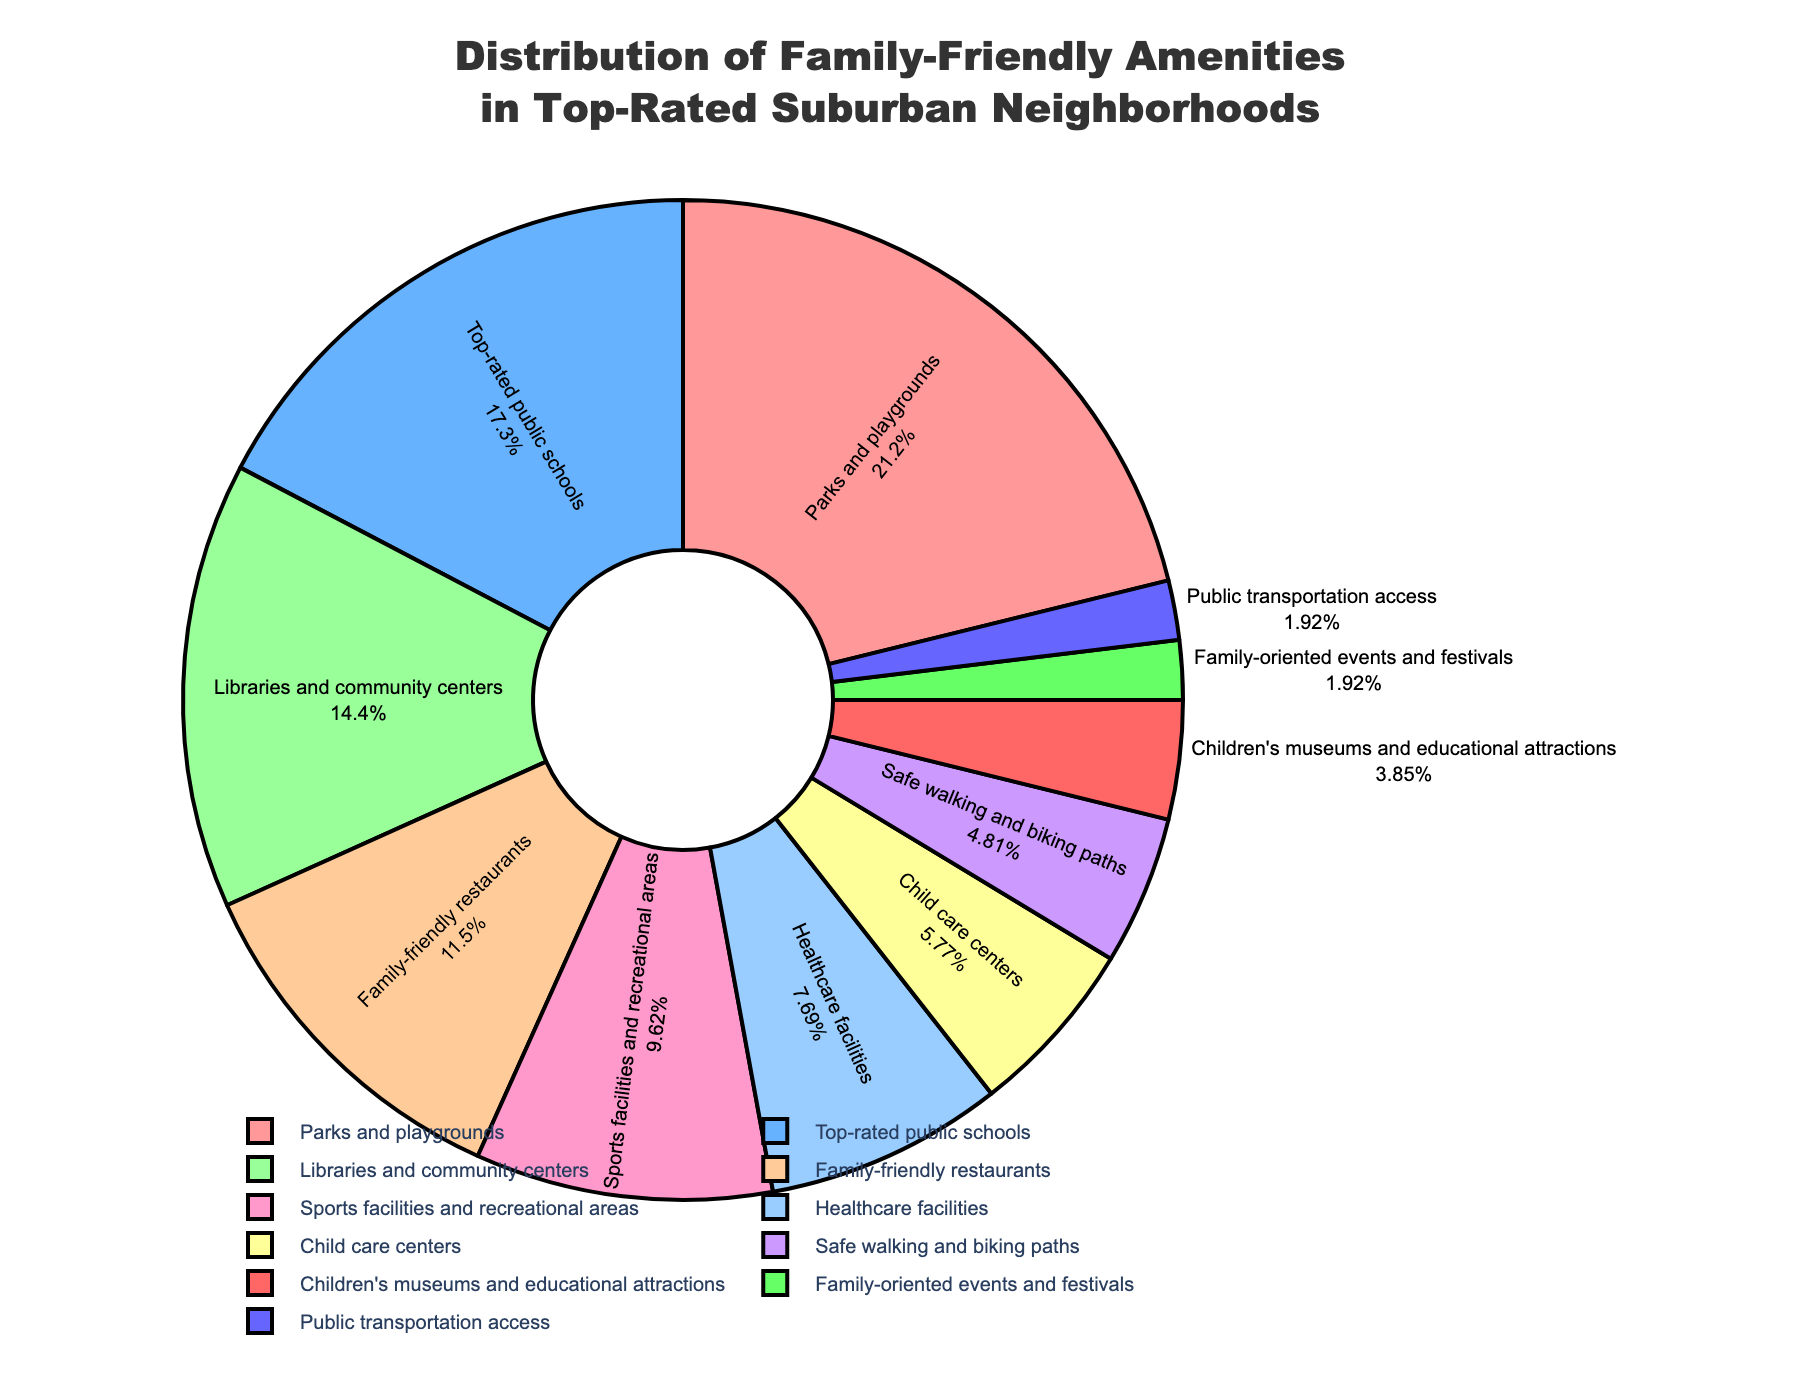Which category has the largest percentage in the distribution? By looking at the percentages in the pie chart, we can identify that 'Parks and playgrounds' has the largest slice of the pie.
Answer: Parks and playgrounds How much larger is the percentage of 'Parks and playgrounds' compared to 'Top-rated public schools'? The percentage for 'Parks and playgrounds' is 22% and for 'Top-rated public schools' is 18%. The difference between them is 22% - 18% = 4%.
Answer: 4% What is the combined percentage of 'Family-friendly restaurants' and 'Sports facilities and recreational areas'? The percentage for 'Family-friendly restaurants' is 12% and 'Sports facilities and recreational areas' is 10%. Adding them gives 12% + 10% = 22%.
Answer: 22% Which amenity category has the second smallest percentage? By examining the slices of the pie chart, the second smallest slice corresponds to 'Family-oriented events and festivals' with 2%. The smallest percentage is 'Public transportation access' which is also 2%, but listed last.
Answer: Family-oriented events and festivals What percentage of amenities accounts for 'Libraries and community centers' and 'Healthcare facilities' together? The percentage for 'Libraries and community centers' is 15% and 'Healthcare facilities' is 8%. Adding these gives 15% + 8% = 23%.
Answer: 23% Which amenity has a percentage closest to 10%? According to the data provided in the pie chart, 'Sports facilities and recreational areas' have a percentage of 10%, which is exactly the value being asked.
Answer: Sports facilities and recreational areas How many amenities categories have a percentage of 10% or greater? By reviewing the chart, the categories with percentages 10% or greater are 'Parks and playgrounds' (22%), 'Top-rated public schools' (18%), 'Libraries and community centers' (15%), 'Family-friendly restaurants' (12%), and 'Sports facilities and recreational areas' (10%), totaling 5 categories.
Answer: 5 What is the difference in the percentages between 'Safe walking and biking paths' and 'Child care centers'? The percentage for 'Safe walking and biking paths' is 5% and 'Child care centers' is 6%. The difference between them is 6% - 5% = 1%.
Answer: 1% Which categories together make up less than 10% of the total distribution? The categories that make up less than 10% are: 'Safe walking and biking paths' (5%), 'Children's museums and educational attractions' (4%), 'Family-oriented events and festivals' (2%), and 'Public transportation access' (2%). Summing them: 5% + 4% + 2% + 2% = 13%. Individually, all these percentages are less than 10%.
Answer: Safe walking and biking paths, Children's museums and educational attractions, Family-oriented events and festivals, Public transportation access 